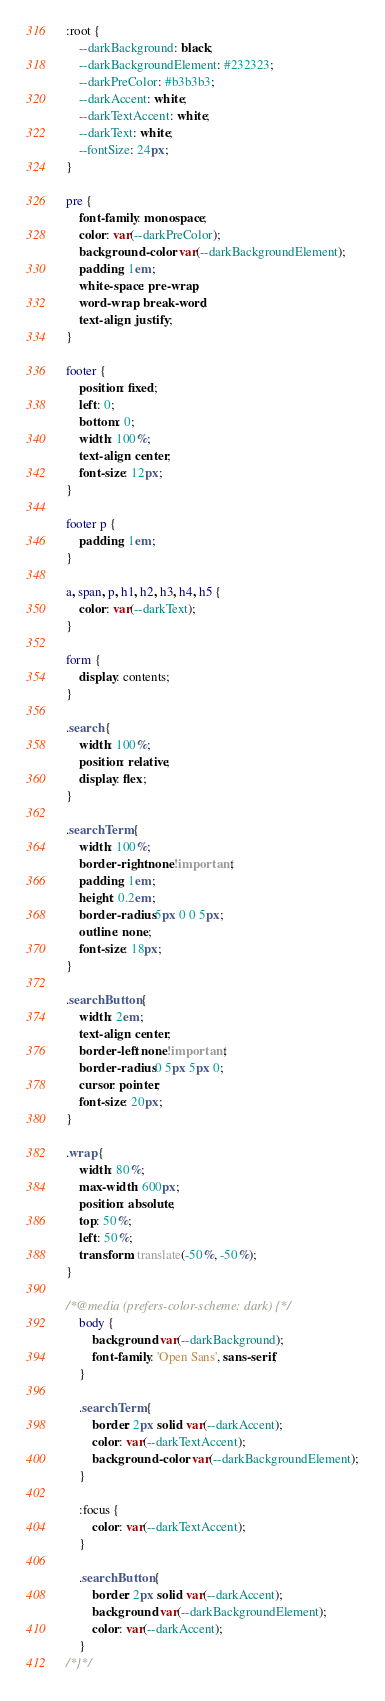Convert code to text. <code><loc_0><loc_0><loc_500><loc_500><_CSS_>:root {
    --darkBackground: black;
    --darkBackgroundElement: #232323;
    --darkPreColor: #b3b3b3;
    --darkAccent: white;
    --darkTextAccent: white;
    --darkText: white;
    --fontSize: 24px;
}

pre {
    font-family: monospace;
    color: var(--darkPreColor);
    background-color: var(--darkBackgroundElement);
    padding: 1em;
    white-space: pre-wrap;
    word-wrap: break-word;
    text-align: justify;
}

footer {
    position: fixed;
    left: 0;
    bottom: 0;
    width: 100%;
    text-align: center;
    font-size: 12px;
}

footer p {
    padding: 1em;
}

a, span, p, h1, h2, h3, h4, h5 {
    color: var(--darkText);
}

form {
    display: contents;
}

.search {
    width: 100%;
    position: relative;
    display: flex;
}

.searchTerm {
    width: 100%;
    border-right: none!important;
    padding: 1em;
    height: 0.2em;
    border-radius: 5px 0 0 5px;
    outline: none;
    font-size: 18px;
}

.searchButton {
    width: 2em;
    text-align: center;
    border-left: none!important;
    border-radius: 0 5px 5px 0;
    cursor: pointer;
    font-size: 20px;
}

.wrap {
    width: 80%;
    max-width: 600px;
    position: absolute;
    top: 50%;
    left: 50%;
    transform: translate(-50%, -50%);
}

/*@media (prefers-color-scheme: dark) {*/
    body {
        background: var(--darkBackground);
        font-family: 'Open Sans', sans-serif;
    }

    .searchTerm {
        border: 2px solid var(--darkAccent);
        color: var(--darkTextAccent);
        background-color: var(--darkBackgroundElement);
    }

    :focus {
        color: var(--darkTextAccent);
    }

    .searchButton {
        border: 2px solid var(--darkAccent);
        background: var(--darkBackgroundElement);
        color: var(--darkAccent);
    }
/*}*/</code> 